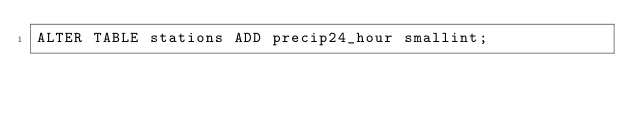Convert code to text. <code><loc_0><loc_0><loc_500><loc_500><_SQL_>ALTER TABLE stations ADD precip24_hour smallint;</code> 